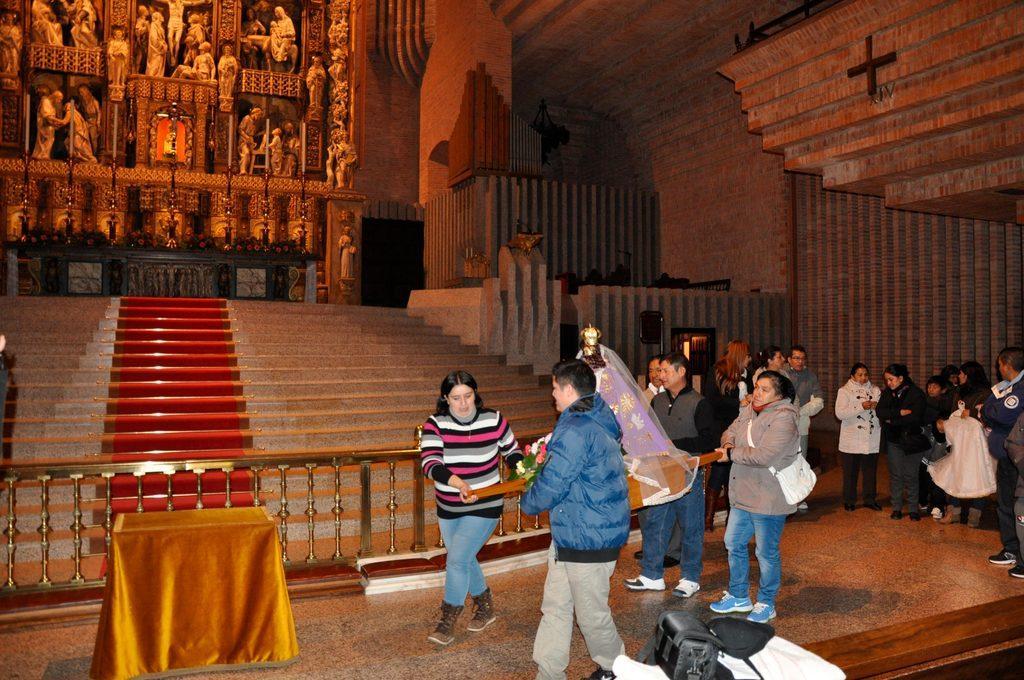Can you describe this image briefly? In the center of the image we can see people standing and holding an object. On the left there is a table. On the right there are people standing. In the background there are stairs and a wall. We can see sculptures on the wall. 